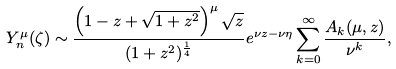Convert formula to latex. <formula><loc_0><loc_0><loc_500><loc_500>Y _ { n } ^ { \mu } ( \zeta ) \sim \frac { \left ( 1 - z + \sqrt { 1 + z ^ { 2 } } \right ) ^ { \mu } \sqrt { z } } { ( 1 + z ^ { 2 } ) ^ { \frac { 1 } { 4 } } } e ^ { \nu z - \nu \eta } \sum _ { k = 0 } ^ { \infty } \frac { A _ { k } ( \mu , z ) } { \nu ^ { k } } ,</formula> 